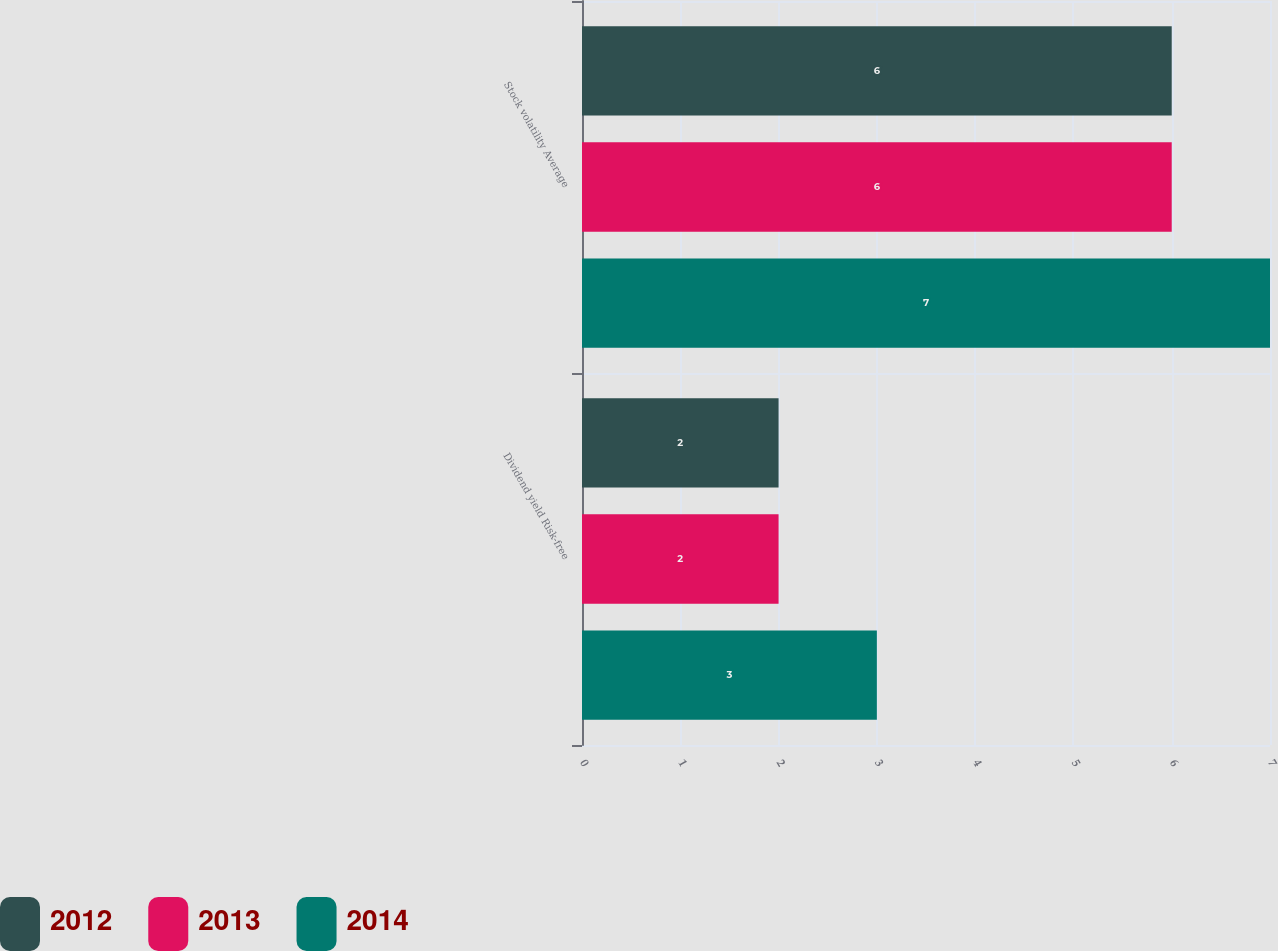Convert chart. <chart><loc_0><loc_0><loc_500><loc_500><stacked_bar_chart><ecel><fcel>Dividend yield Risk-free<fcel>Stock volatility Average<nl><fcel>2012<fcel>2<fcel>6<nl><fcel>2013<fcel>2<fcel>6<nl><fcel>2014<fcel>3<fcel>7<nl></chart> 